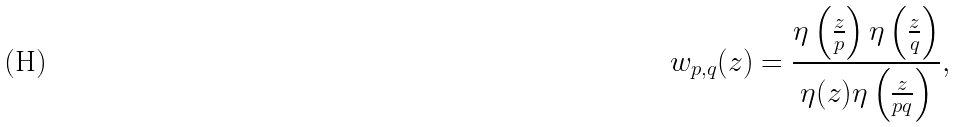<formula> <loc_0><loc_0><loc_500><loc_500>w _ { p , q } ( z ) = \frac { \eta \left ( \frac { z } { p } \right ) \eta \left ( \frac { z } { q } \right ) } { \eta ( z ) \eta \left ( \frac { z } { p q } \right ) } ,</formula> 